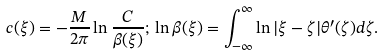<formula> <loc_0><loc_0><loc_500><loc_500>c ( \xi ) = - \frac { M } { 2 \pi } \ln \frac { C } { \beta ( \xi ) } ; \, \ln \beta ( \xi ) = \int _ { - \infty } ^ { \infty } \ln | \xi - \zeta | \theta ^ { \prime } ( \zeta ) d \zeta .</formula> 